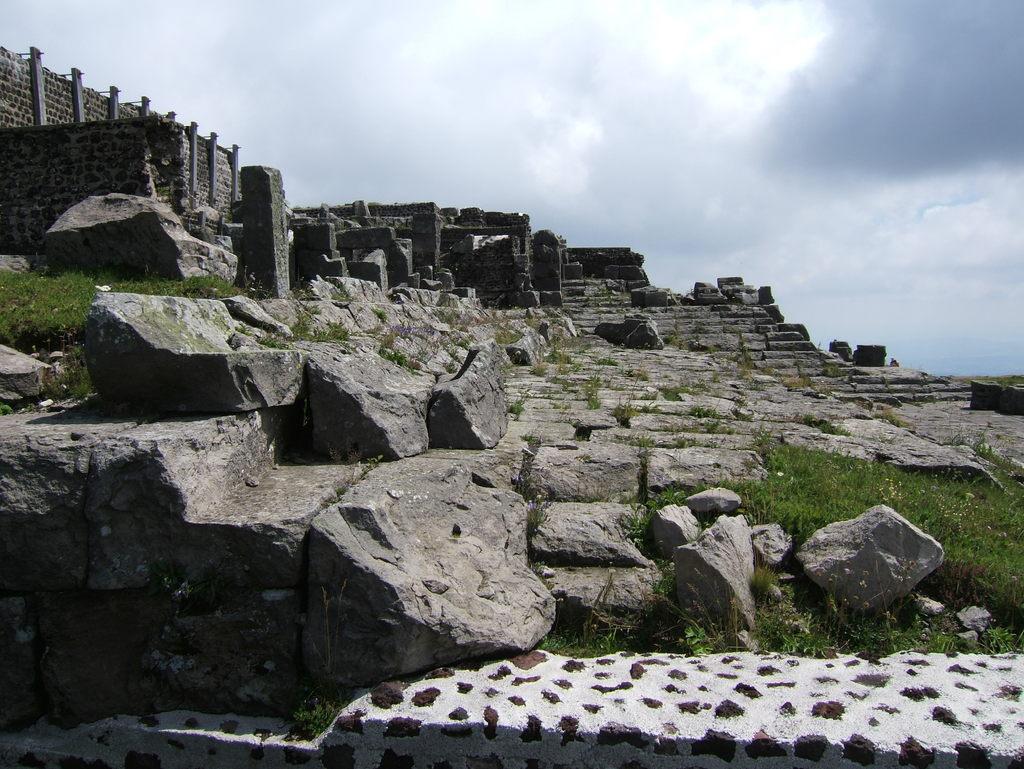Can you describe this image briefly? In this image we can see the grass, rocks, stone wall and the cloudy sky in the background. 